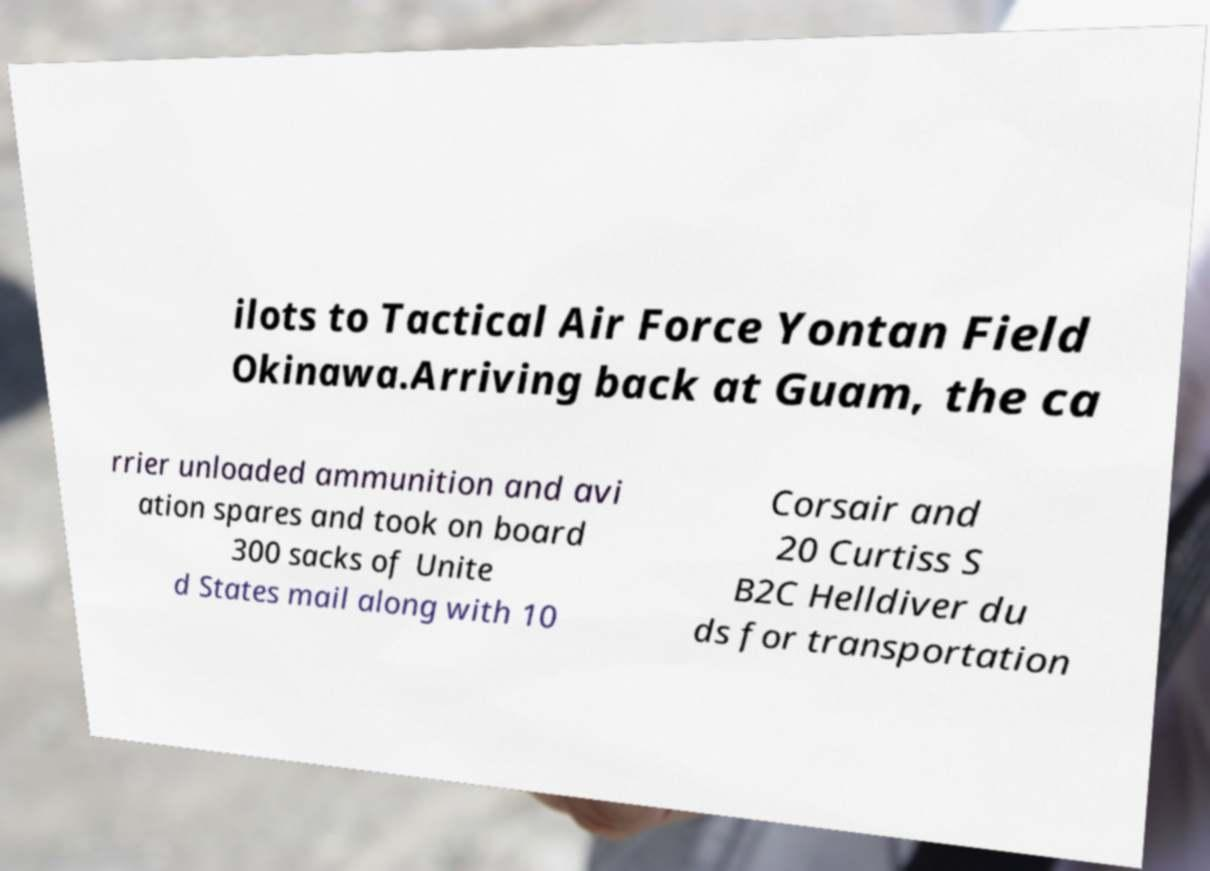There's text embedded in this image that I need extracted. Can you transcribe it verbatim? ilots to Tactical Air Force Yontan Field Okinawa.Arriving back at Guam, the ca rrier unloaded ammunition and avi ation spares and took on board 300 sacks of Unite d States mail along with 10 Corsair and 20 Curtiss S B2C Helldiver du ds for transportation 